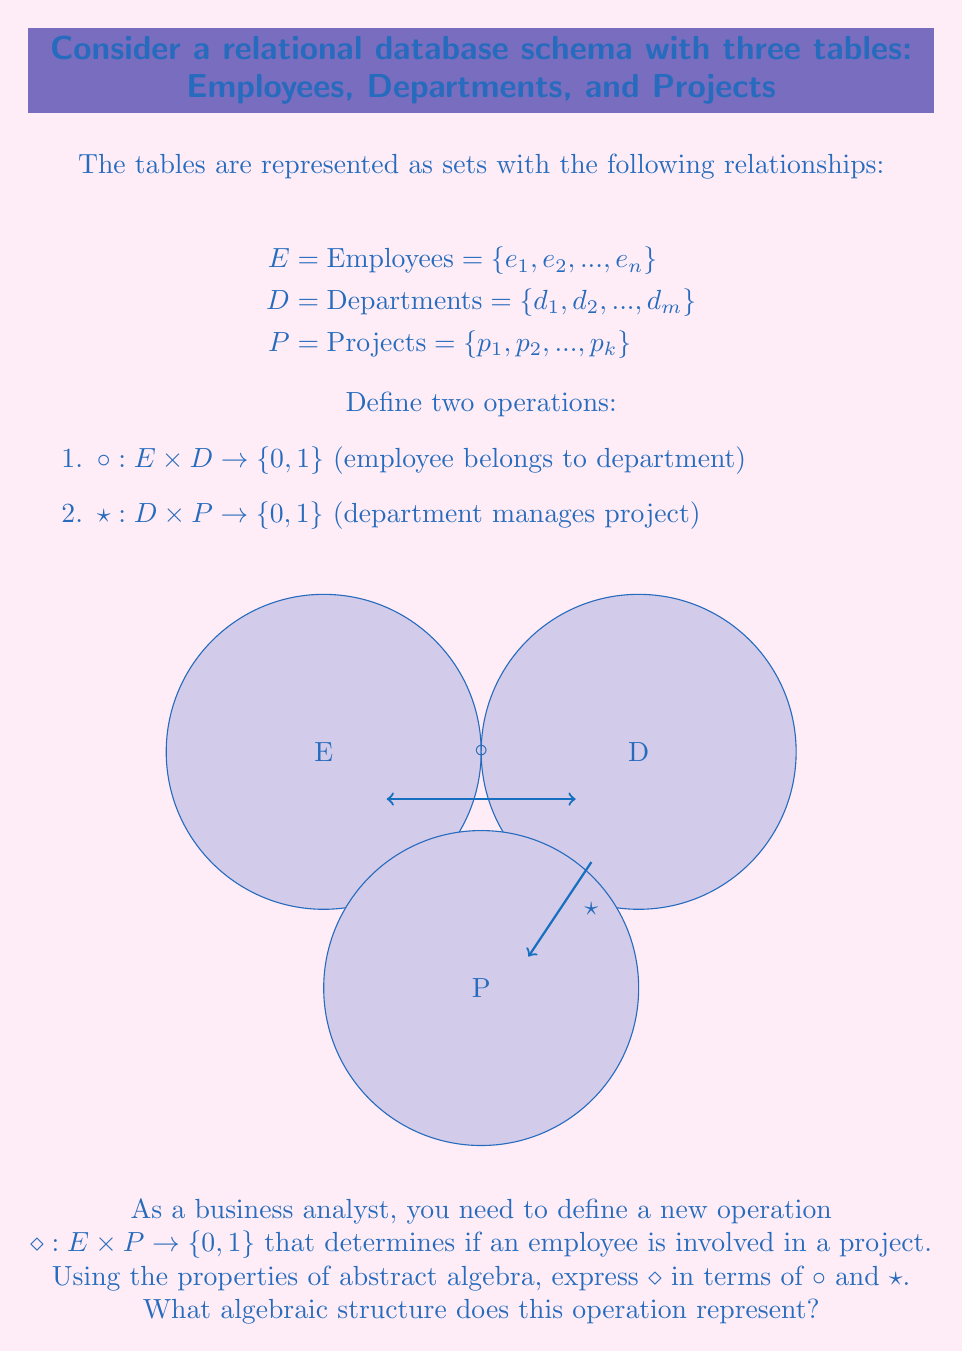What is the answer to this math problem? To solve this problem, we need to follow these steps:

1. Analyze the given operations:
   - $\circ: E \times D \to \{0,1\}$ (employee belongs to department)
   - $\star: D \times P \to \{0,1\}$ (department manages project)

2. Define the new operation $\diamond: E \times P \to \{0,1\}$ (employee is involved in a project)

3. Express $\diamond$ in terms of $\circ$ and $\star$:
   An employee is involved in a project if they belong to a department that manages the project. This can be expressed as:

   $$\diamond(e,p) = \bigvee_{d \in D} (\circ(e,d) \wedge \star(d,p))$$

   Where $\bigvee$ represents the logical OR operation over all departments.

4. Analyze the algebraic structure:
   - The operation $\diamond$ is a composition of $\circ$ and $\star$ through an intermediate set $D$.
   - This structure resembles a relational join operation in database theory.
   - In abstract algebra, this structure is similar to a binary relation composition.

5. Identify the algebraic properties:
   - Closure: The result of $\diamond$ is always in $\{0,1\}$
   - Associativity: $(a \diamond b) \diamond c = a \diamond (b \diamond c)$ (if we extend $\diamond$ to be applicable between any two of $E$, $D$, and $P$)
   - Identity element: There's no natural identity element
   - Inverse elements: Not applicable in this context

Given these properties, the algebraic structure represented by $\diamond$ is a semigroupoid, which is a generalization of a semigroup where the binary operation is not necessarily defined for all pairs of elements.
Answer: Semigroupoid 